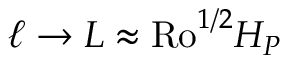Convert formula to latex. <formula><loc_0><loc_0><loc_500><loc_500>\ell \rightarrow L \approx R o ^ { 1 / 2 } H _ { P }</formula> 